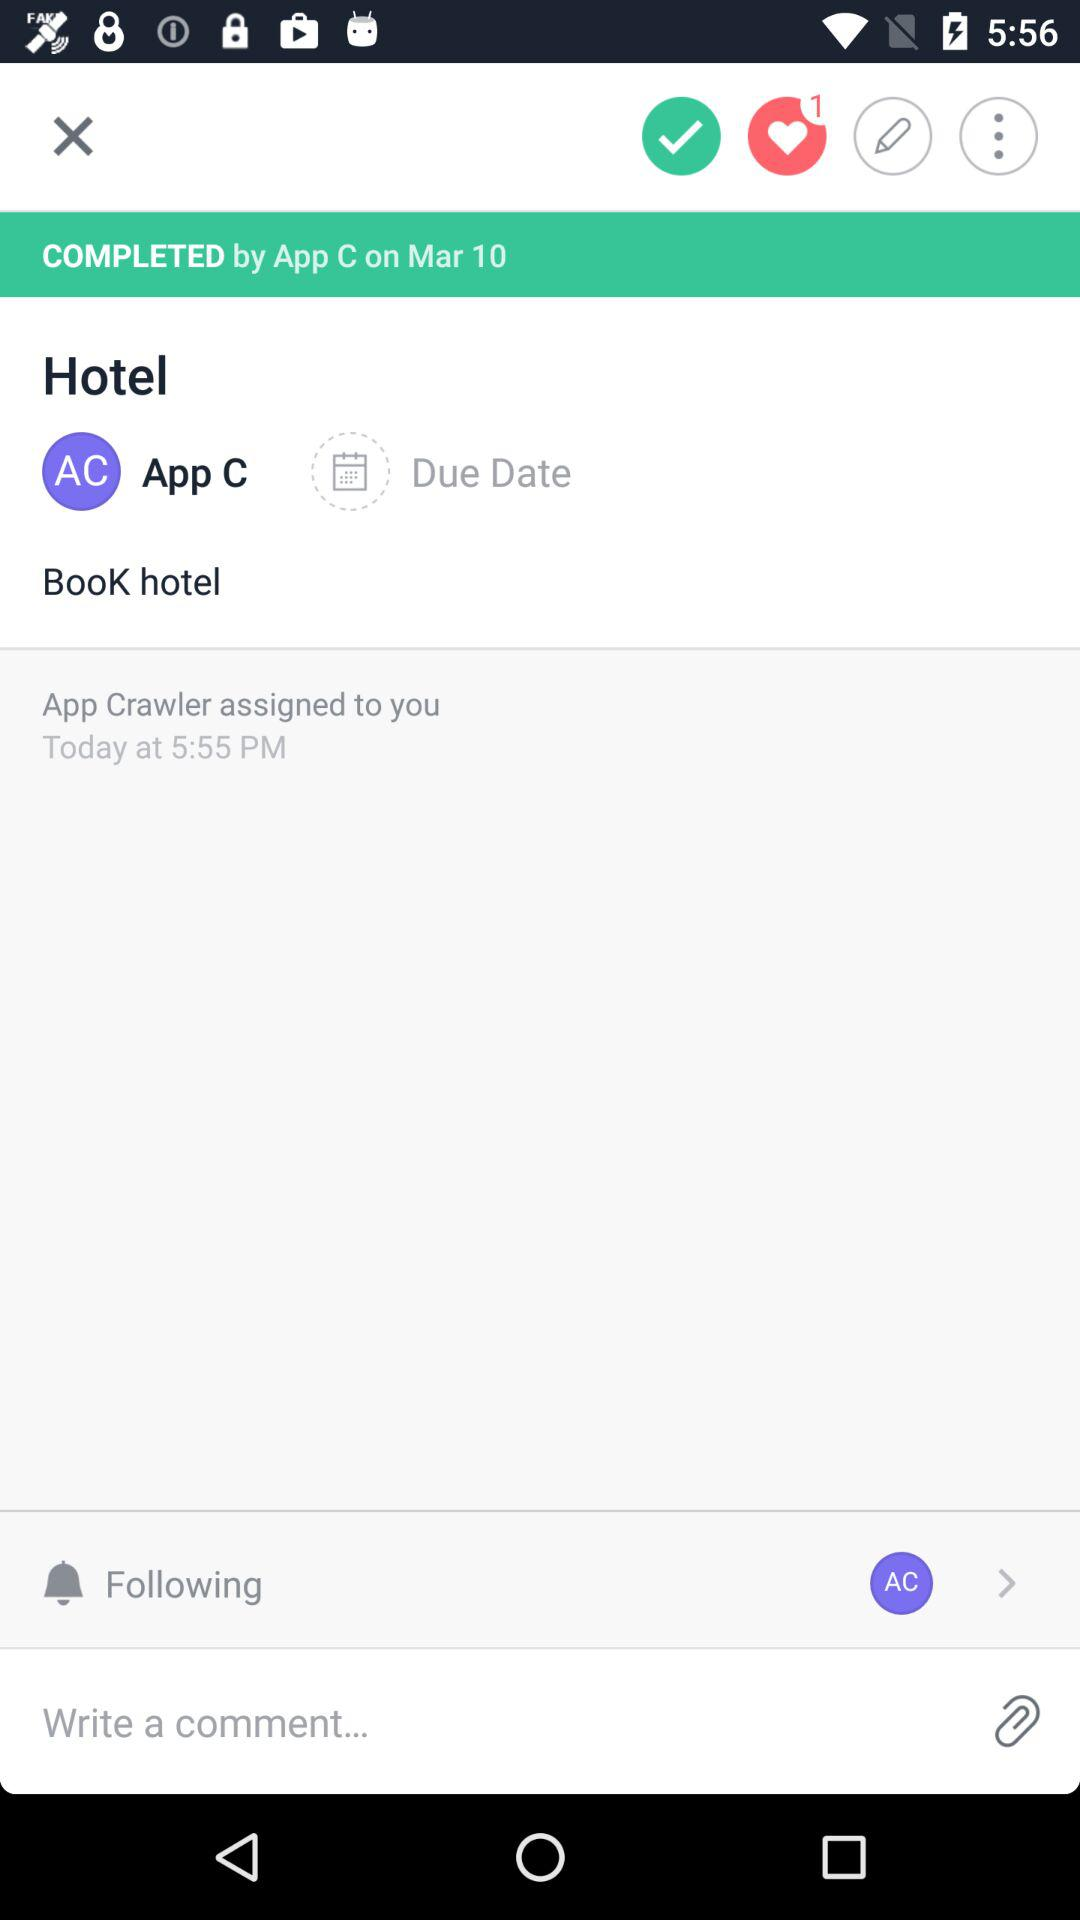What is the name of the application?
When the provided information is insufficient, respond with <no answer>. <no answer> 